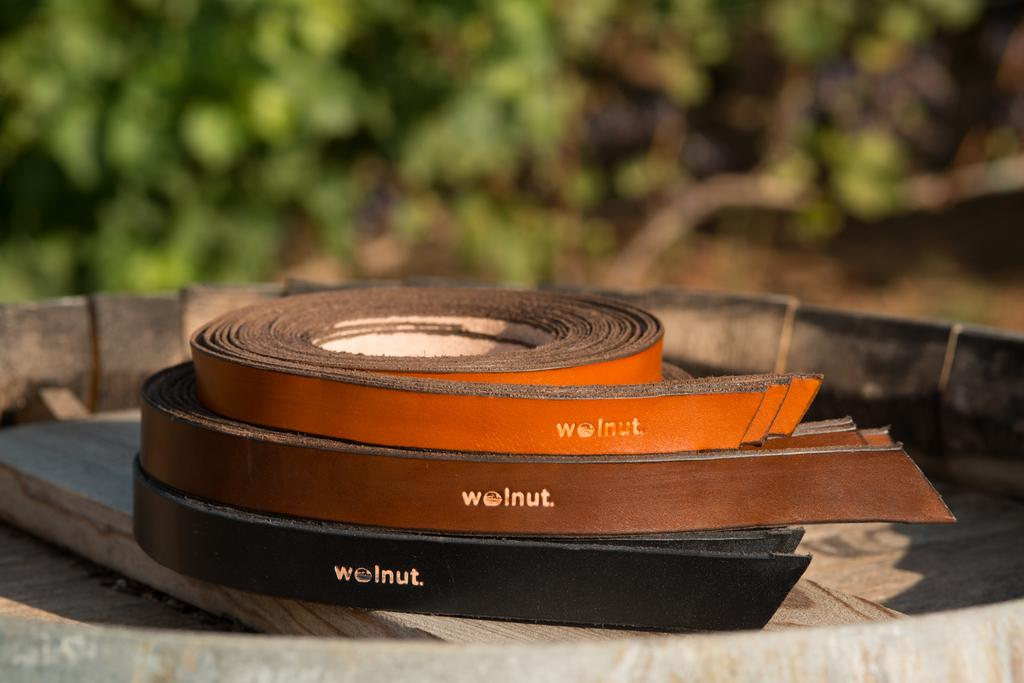How many belts are visible in the image? There are three belts in the image. What is the belts placed on in the image? The belts are placed on a wooden object. What type of chalk is being used to write on the mailbox in the image? There is no mailbox or chalk present in the image. 